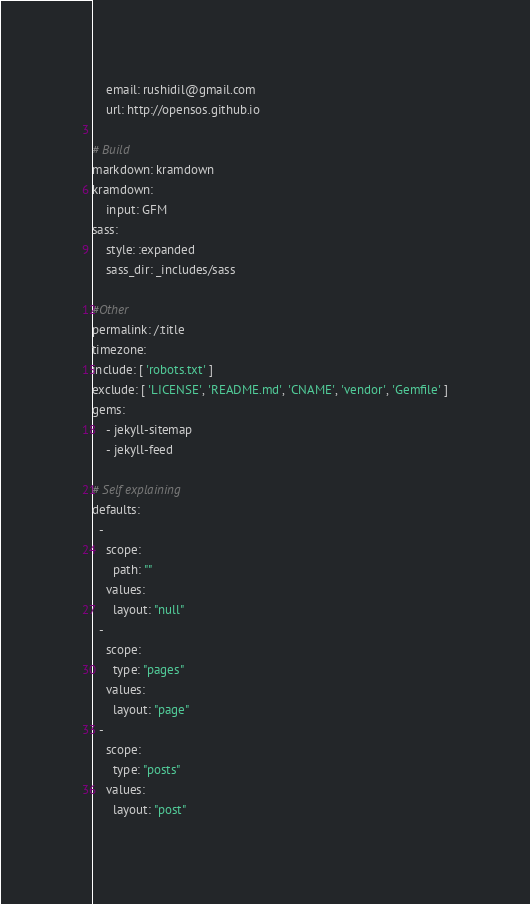<code> <loc_0><loc_0><loc_500><loc_500><_YAML_>    email: rushidil@gmail.com
    url: http://opensos.github.io

# Build
markdown: kramdown
kramdown:
    input: GFM
sass:
    style: :expanded
    sass_dir: _includes/sass

#Other
permalink: /:title
timezone: 
include: [ 'robots.txt' ]
exclude: [ 'LICENSE', 'README.md', 'CNAME', 'vendor', 'Gemfile' ]
gems:
    - jekyll-sitemap
    - jekyll-feed

# Self explaining
defaults:
  -
    scope:
      path: ""
    values:
      layout: "null"
  -
    scope:
      type: "pages"
    values:
      layout: "page"
  -
    scope:
      type: "posts"
    values:
      layout: "post"</code> 